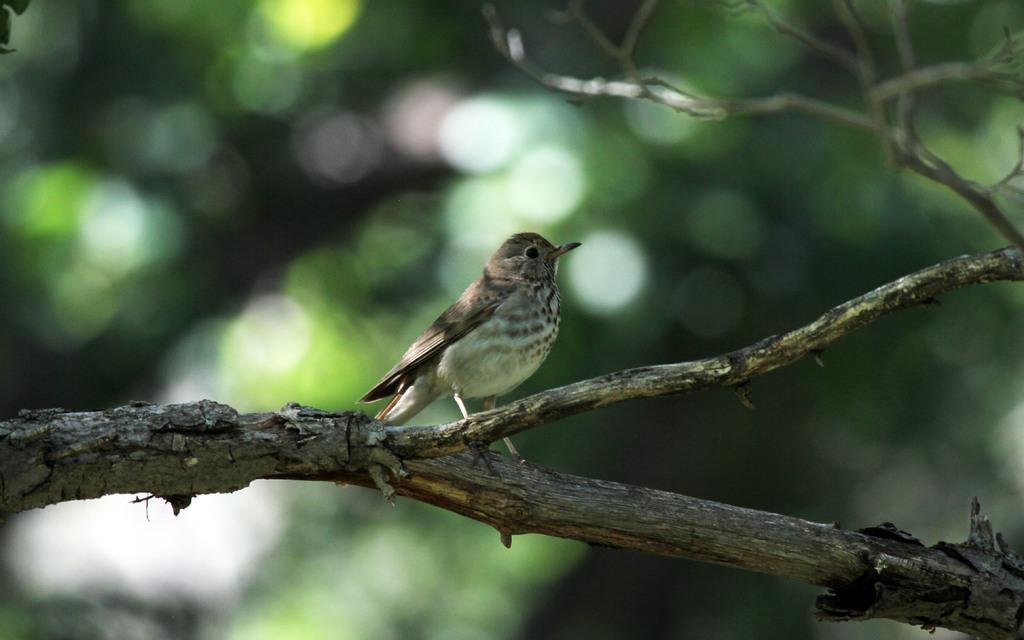How would you summarize this image in a sentence or two? In this picture we can see a bird standing on the trees stem. 